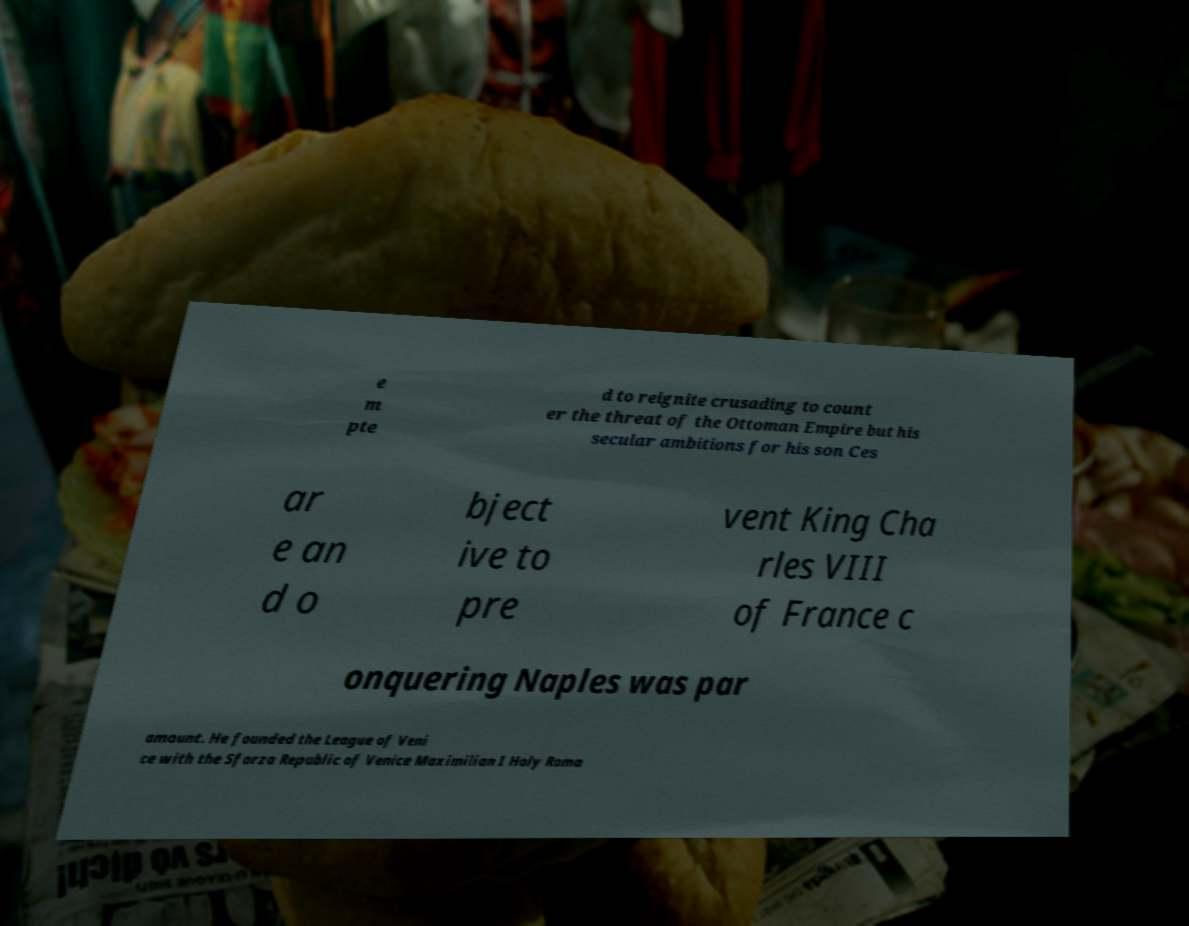For documentation purposes, I need the text within this image transcribed. Could you provide that? e m pte d to reignite crusading to count er the threat of the Ottoman Empire but his secular ambitions for his son Ces ar e an d o bject ive to pre vent King Cha rles VIII of France c onquering Naples was par amount. He founded the League of Veni ce with the Sforza Republic of Venice Maximilian I Holy Roma 